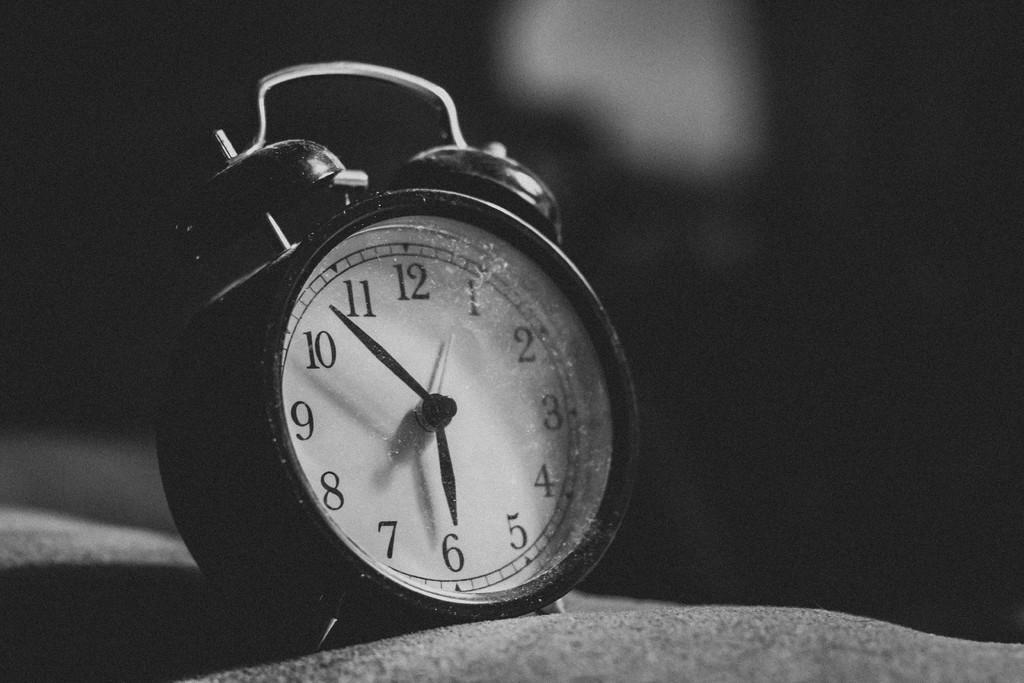Can you describe this image briefly? It is a clock in white color. This is the black and white image. 